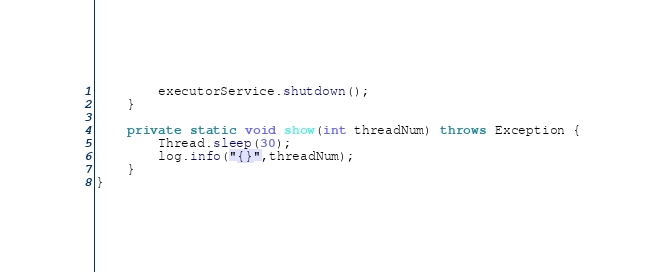<code> <loc_0><loc_0><loc_500><loc_500><_Java_>        executorService.shutdown();
    }

    private static void show(int threadNum) throws Exception {
        Thread.sleep(30);
        log.info("{}",threadNum);
    }
}
</code> 